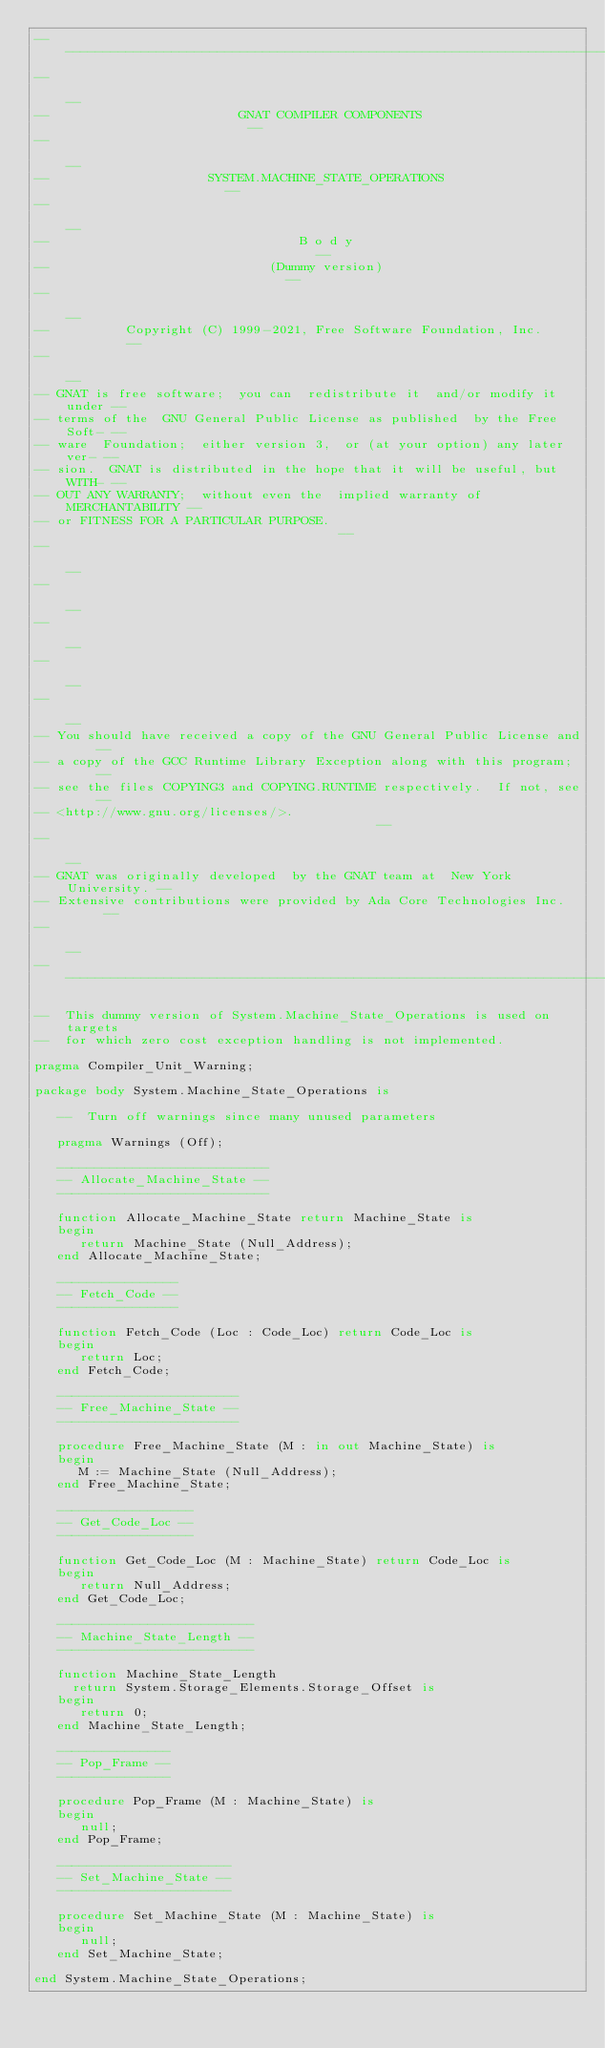<code> <loc_0><loc_0><loc_500><loc_500><_Ada_>------------------------------------------------------------------------------
--                                                                          --
--                         GNAT COMPILER COMPONENTS                         --
--                                                                          --
--                     SYSTEM.MACHINE_STATE_OPERATIONS                      --
--                                                                          --
--                                 B o d y                                  --
--                             (Dummy version)                              --
--                                                                          --
--          Copyright (C) 1999-2021, Free Software Foundation, Inc.         --
--                                                                          --
-- GNAT is free software;  you can  redistribute it  and/or modify it under --
-- terms of the  GNU General Public License as published  by the Free Soft- --
-- ware  Foundation;  either version 3,  or (at your option) any later ver- --
-- sion.  GNAT is distributed in the hope that it will be useful, but WITH- --
-- OUT ANY WARRANTY;  without even the  implied warranty of MERCHANTABILITY --
-- or FITNESS FOR A PARTICULAR PURPOSE.                                     --
--                                                                          --
--                                                                          --
--                                                                          --
--                                                                          --
--                                                                          --
-- You should have received a copy of the GNU General Public License and    --
-- a copy of the GCC Runtime Library Exception along with this program;     --
-- see the files COPYING3 and COPYING.RUNTIME respectively.  If not, see    --
-- <http://www.gnu.org/licenses/>.                                          --
--                                                                          --
-- GNAT was originally developed  by the GNAT team at  New York University. --
-- Extensive contributions were provided by Ada Core Technologies Inc.      --
--                                                                          --
------------------------------------------------------------------------------

--  This dummy version of System.Machine_State_Operations is used on targets
--  for which zero cost exception handling is not implemented.

pragma Compiler_Unit_Warning;

package body System.Machine_State_Operations is

   --  Turn off warnings since many unused parameters

   pragma Warnings (Off);

   ----------------------------
   -- Allocate_Machine_State --
   ----------------------------

   function Allocate_Machine_State return Machine_State is
   begin
      return Machine_State (Null_Address);
   end Allocate_Machine_State;

   ----------------
   -- Fetch_Code --
   ----------------

   function Fetch_Code (Loc : Code_Loc) return Code_Loc is
   begin
      return Loc;
   end Fetch_Code;

   ------------------------
   -- Free_Machine_State --
   ------------------------

   procedure Free_Machine_State (M : in out Machine_State) is
   begin
      M := Machine_State (Null_Address);
   end Free_Machine_State;

   ------------------
   -- Get_Code_Loc --
   ------------------

   function Get_Code_Loc (M : Machine_State) return Code_Loc is
   begin
      return Null_Address;
   end Get_Code_Loc;

   --------------------------
   -- Machine_State_Length --
   --------------------------

   function Machine_State_Length
     return System.Storage_Elements.Storage_Offset is
   begin
      return 0;
   end Machine_State_Length;

   ---------------
   -- Pop_Frame --
   ---------------

   procedure Pop_Frame (M : Machine_State) is
   begin
      null;
   end Pop_Frame;

   -----------------------
   -- Set_Machine_State --
   -----------------------

   procedure Set_Machine_State (M : Machine_State) is
   begin
      null;
   end Set_Machine_State;

end System.Machine_State_Operations;
</code> 